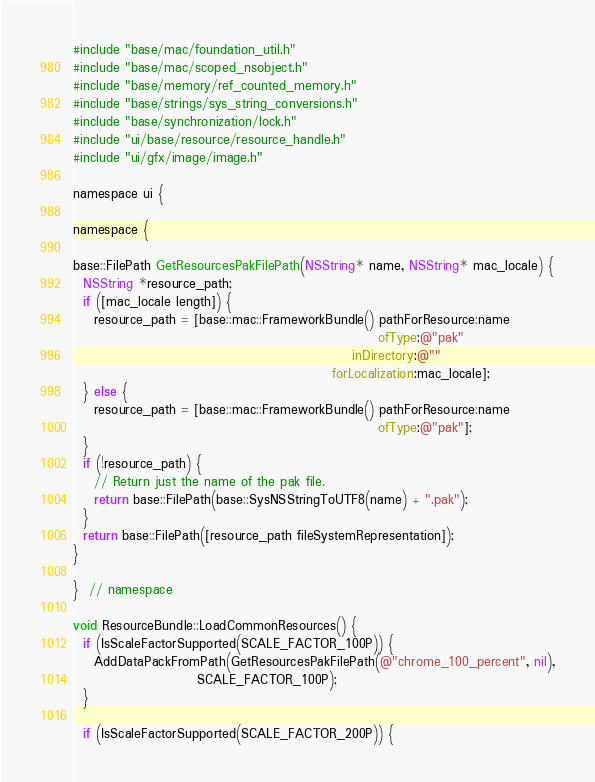Convert code to text. <code><loc_0><loc_0><loc_500><loc_500><_ObjectiveC_>#include "base/mac/foundation_util.h"
#include "base/mac/scoped_nsobject.h"
#include "base/memory/ref_counted_memory.h"
#include "base/strings/sys_string_conversions.h"
#include "base/synchronization/lock.h"
#include "ui/base/resource/resource_handle.h"
#include "ui/gfx/image/image.h"

namespace ui {

namespace {

base::FilePath GetResourcesPakFilePath(NSString* name, NSString* mac_locale) {
  NSString *resource_path;
  if ([mac_locale length]) {
    resource_path = [base::mac::FrameworkBundle() pathForResource:name
                                                           ofType:@"pak"
                                                      inDirectory:@""
                                                  forLocalization:mac_locale];
  } else {
    resource_path = [base::mac::FrameworkBundle() pathForResource:name
                                                           ofType:@"pak"];
  }
  if (!resource_path) {
    // Return just the name of the pak file.
    return base::FilePath(base::SysNSStringToUTF8(name) + ".pak");
  }
  return base::FilePath([resource_path fileSystemRepresentation]);
}

}  // namespace

void ResourceBundle::LoadCommonResources() {
  if (IsScaleFactorSupported(SCALE_FACTOR_100P)) {
    AddDataPackFromPath(GetResourcesPakFilePath(@"chrome_100_percent", nil),
                        SCALE_FACTOR_100P);
  }

  if (IsScaleFactorSupported(SCALE_FACTOR_200P)) {</code> 